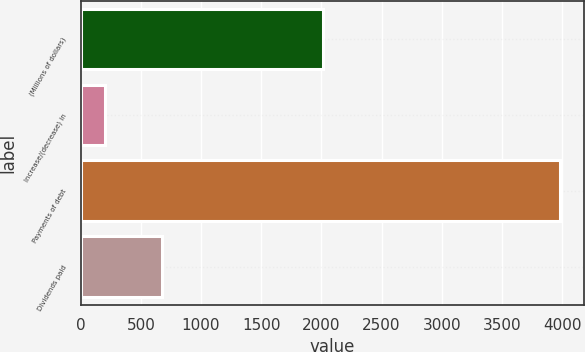Convert chart. <chart><loc_0><loc_0><loc_500><loc_500><bar_chart><fcel>(Millions of dollars)<fcel>Increase/(decrease) in<fcel>Payments of debt<fcel>Dividends paid<nl><fcel>2017<fcel>200<fcel>3980<fcel>677<nl></chart> 